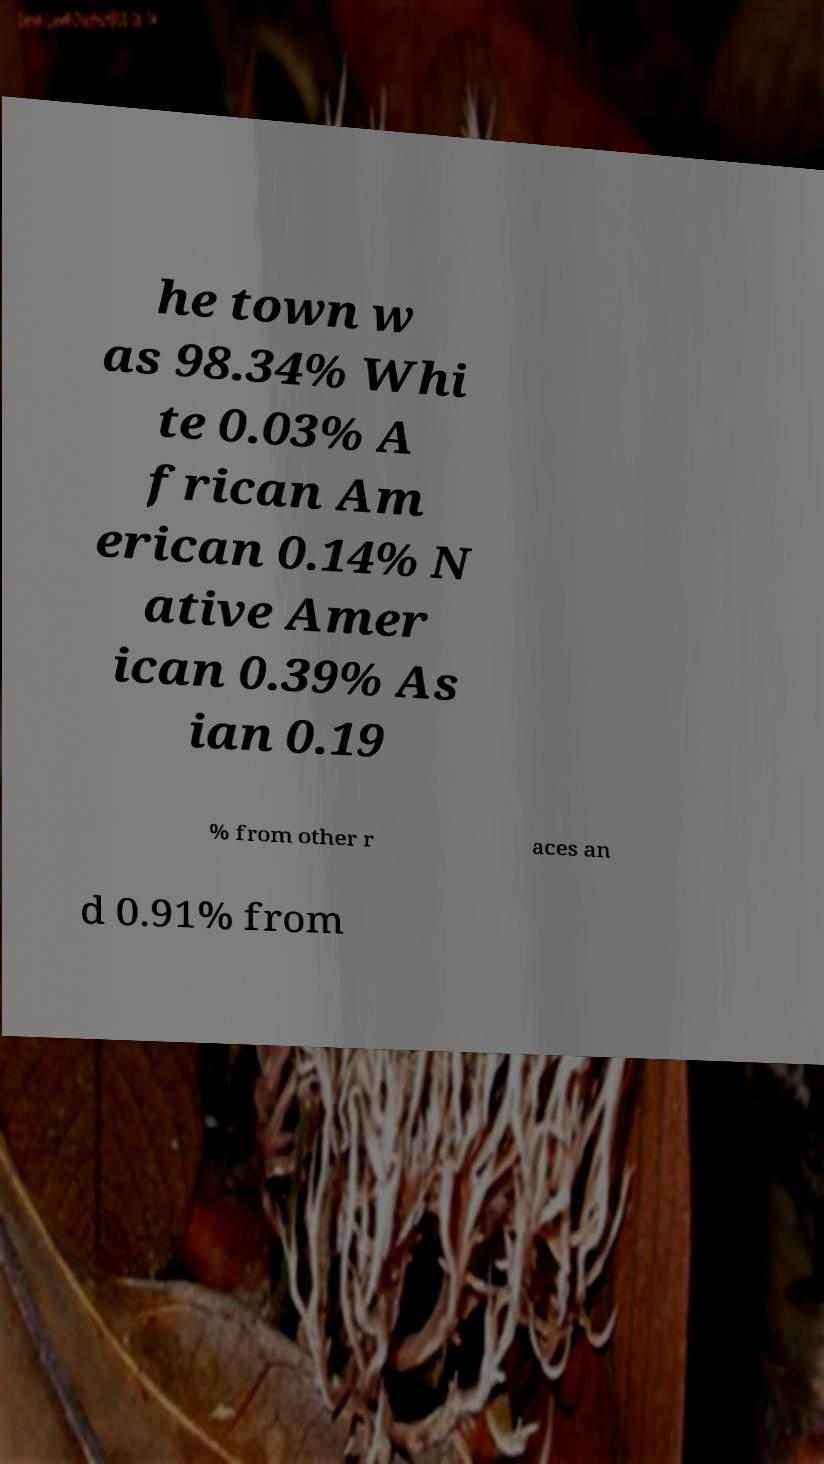Could you extract and type out the text from this image? he town w as 98.34% Whi te 0.03% A frican Am erican 0.14% N ative Amer ican 0.39% As ian 0.19 % from other r aces an d 0.91% from 